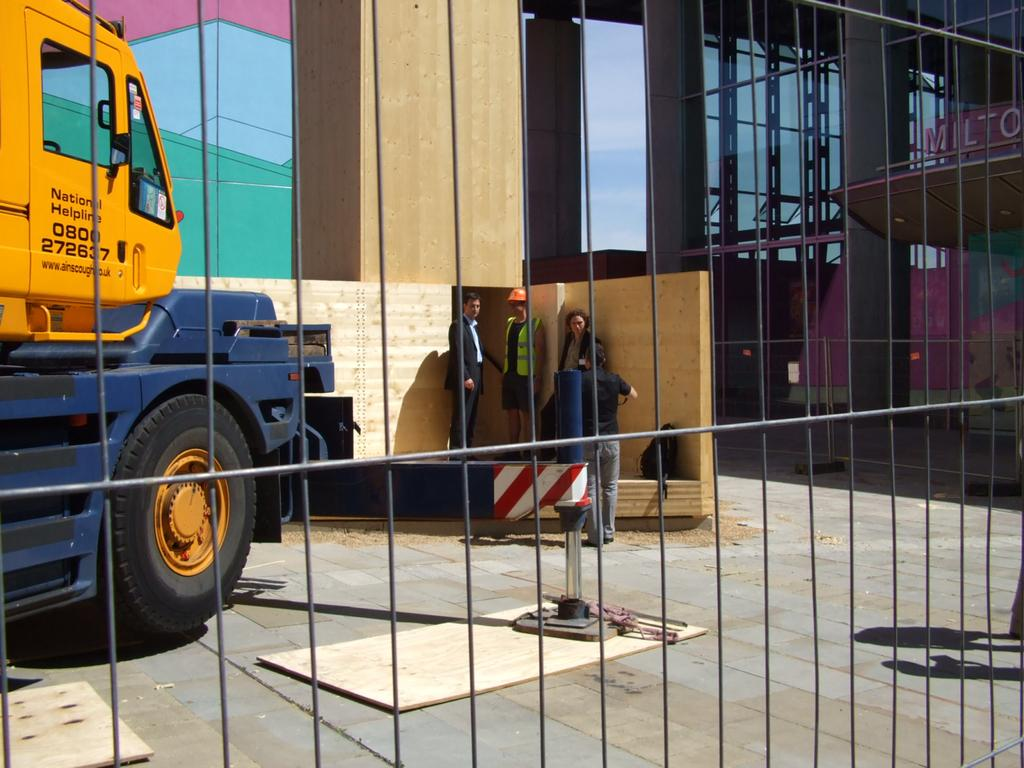What is located on the left side of the image? There is a vehicle parked on the left side of the image. What can be seen on the right side of the image? There are people standing on the right side of the image. What is visible in the background of the image? There is a building in the background of the image. What type of glue is being used by the cattle in the image? There are no cattle or glue present in the image. Is there a church visible in the image? No, there is no church visible in the image; only a vehicle, people, and a building are present. 